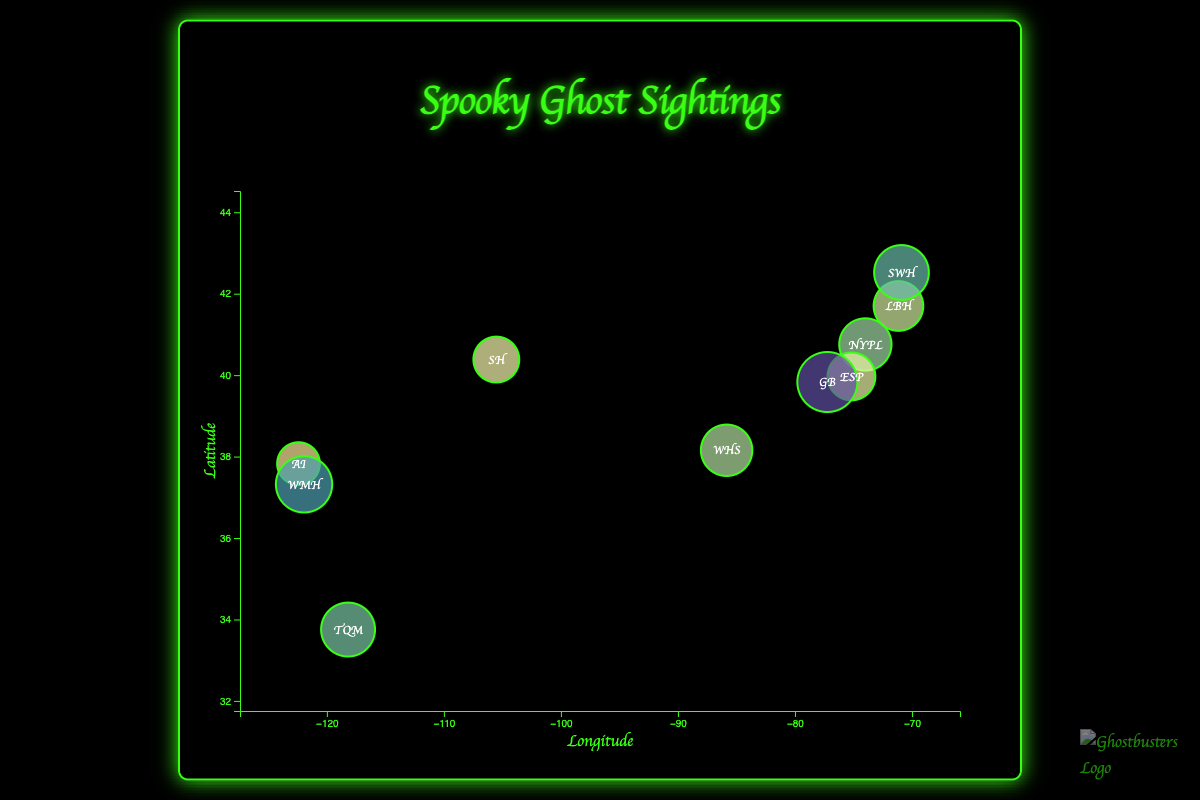How many ghost sightings are represented in the chart? Count the number of bubbles displayed in the chart. Each bubble represents a ghost sighting.
Answer: 10 What is the location with the highest frequency of ghost sightings? Identify the largest bubble on the chart and read the corresponding label.
Answer: Gettysburg Battlefield Which location has fewer sightings: Alcatraz Island or Lizzie Borden House? Compare the sizes of the bubbles for Alcatraz Island and Lizzie Borden House. The bubble size indicates frequency.
Answer: Alcatraz Island What is the geographic region with the southernmost ghost sighting? Find the bubble located at the lowest y-coordinate on the chart, representing the most southern latitude.
Answer: The Queen Mary What is the total frequency of ghost sightings at the New York Public Library and the Stanley Hotel? Identify the bubbles for the New York Public Library and the Stanley Hotel. Add their sighting frequencies: 25 (New York Public Library) + 18 (Stanley Hotel).
Answer: 43 Which location has more ghost sightings, Winchester Mystery House or Salem Witch House? Compare the sizes of the bubbles for Winchester Mystery House and Salem Witch House.
Answer: Winchester Mystery House Which ghost sighting location is closest to the central latitude of the chart? Find the bubble closest to the central y-coordinate (average latitude) of the chart.
Answer: Gettysburg Battlefield What is the frequency range of ghost sightings across all locations? Determine the minimum and maximum frequencies: the smallest bubble (15, Alcatraz Island) and the largest bubble (35, Gettysburg Battlefield). Subtract the minimum from the maximum: 35 - 15.
Answer: 20 Which location has a latitude closest to 40? Find the bubble whose latitude (y-coordinate) is nearest to 40.
Answer: New York Public Library 